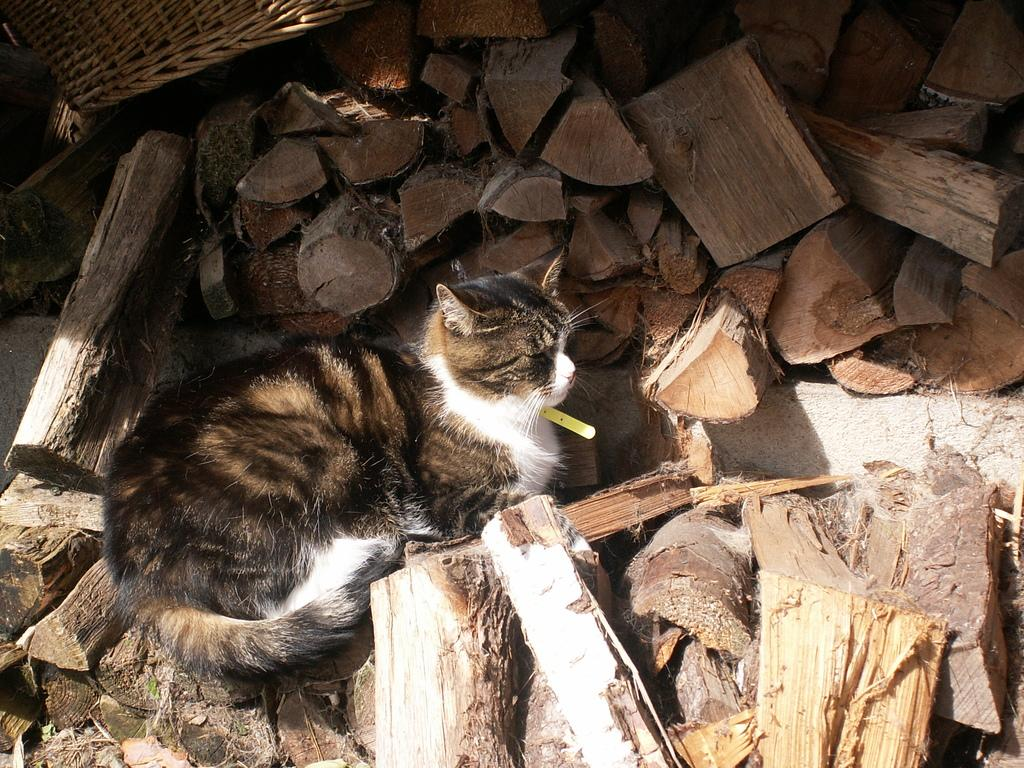What type of animal is in the image? There is a cat in the image. Can you describe the color of the cat? The cat is brown and white in color. Where is the cat positioned in the image? The cat is sitting in the middle of the image. What is surrounding the cat in the image? There are small wooden rafters surrounding the cat. What role does the actor play in the image? There is no actor present in the image; it features a cat sitting on small wooden rafters. Can you tell me how many grapes are visible in the image? There are no grapes present in the image. 